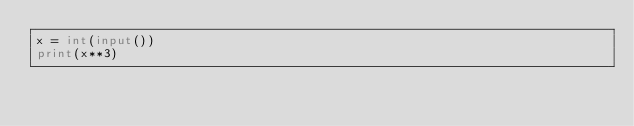Convert code to text. <code><loc_0><loc_0><loc_500><loc_500><_Python_>x = int(input())
print(x**3)
</code> 